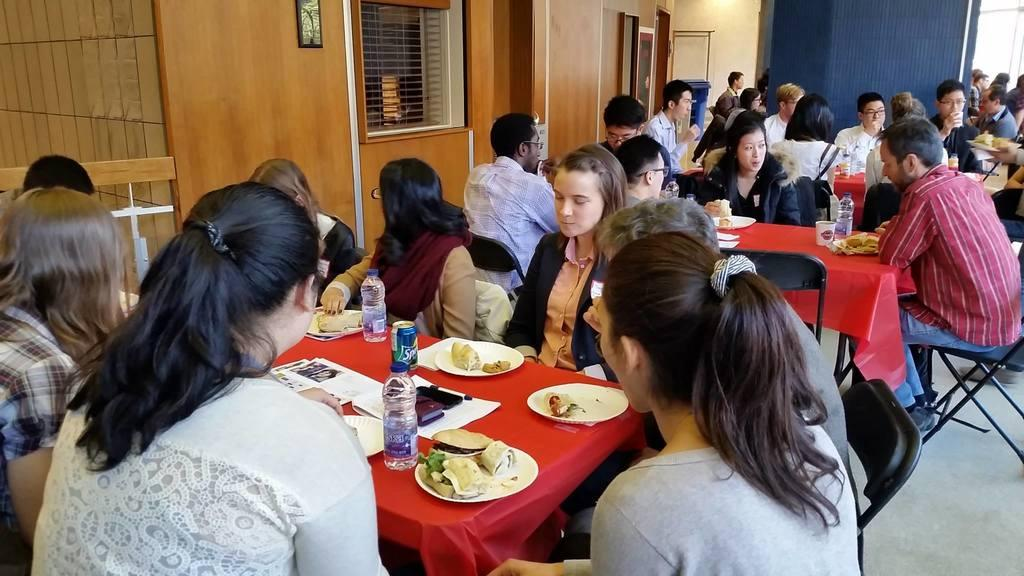How many people are in the image? There is a group of people in the image. What are the people doing in the image? The people are sitting on chairs. What objects are in front of the people? There are tables in front of the people. What type of food can be seen in the image? Food is present in the image. What type of beverages are visible in the image? Cool drinks and bottles of water are present in the image. How does the idea support the recess in the image? There is no mention of an idea, support, or recess in the image. 